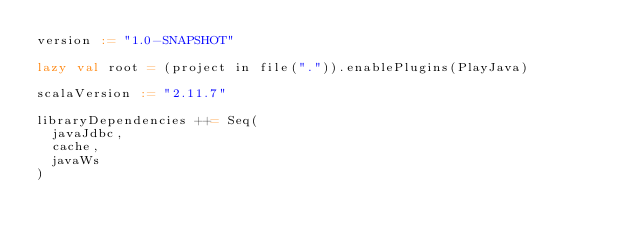<code> <loc_0><loc_0><loc_500><loc_500><_Scala_>version := "1.0-SNAPSHOT"

lazy val root = (project in file(".")).enablePlugins(PlayJava)

scalaVersion := "2.11.7"

libraryDependencies ++= Seq(
  javaJdbc,
  cache,
  javaWs
)
</code> 